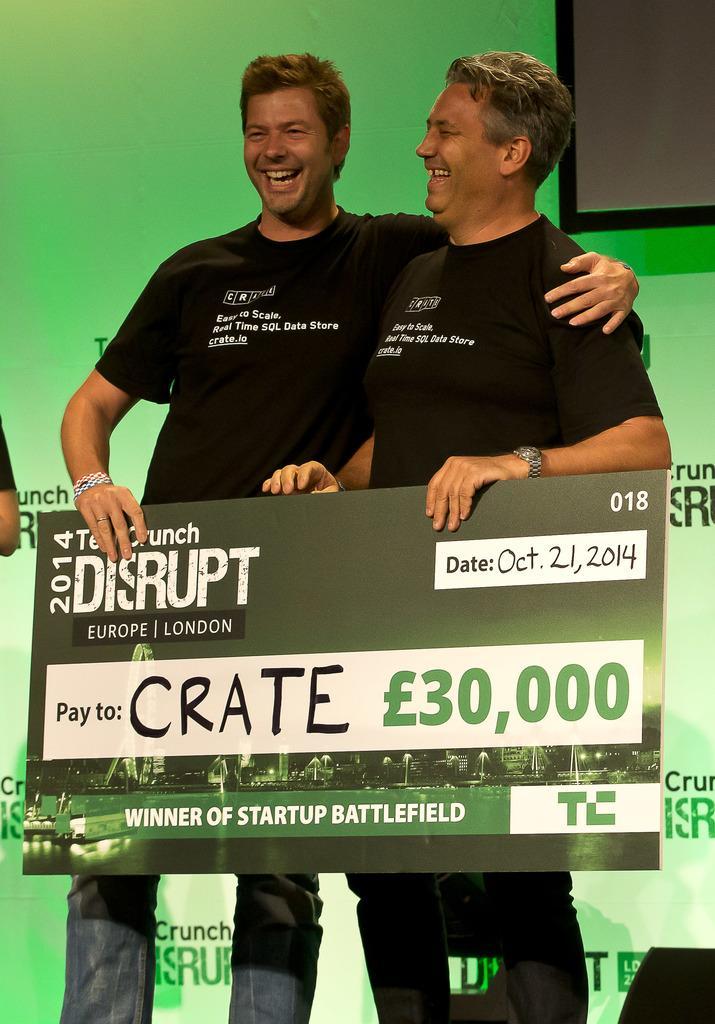Could you give a brief overview of what you see in this image? In the foreground of this image, there are two men wearing black T shirts are standing and holding a board which looks like a cheque board. In the background, there is a green banner wall and a screen at the top. 